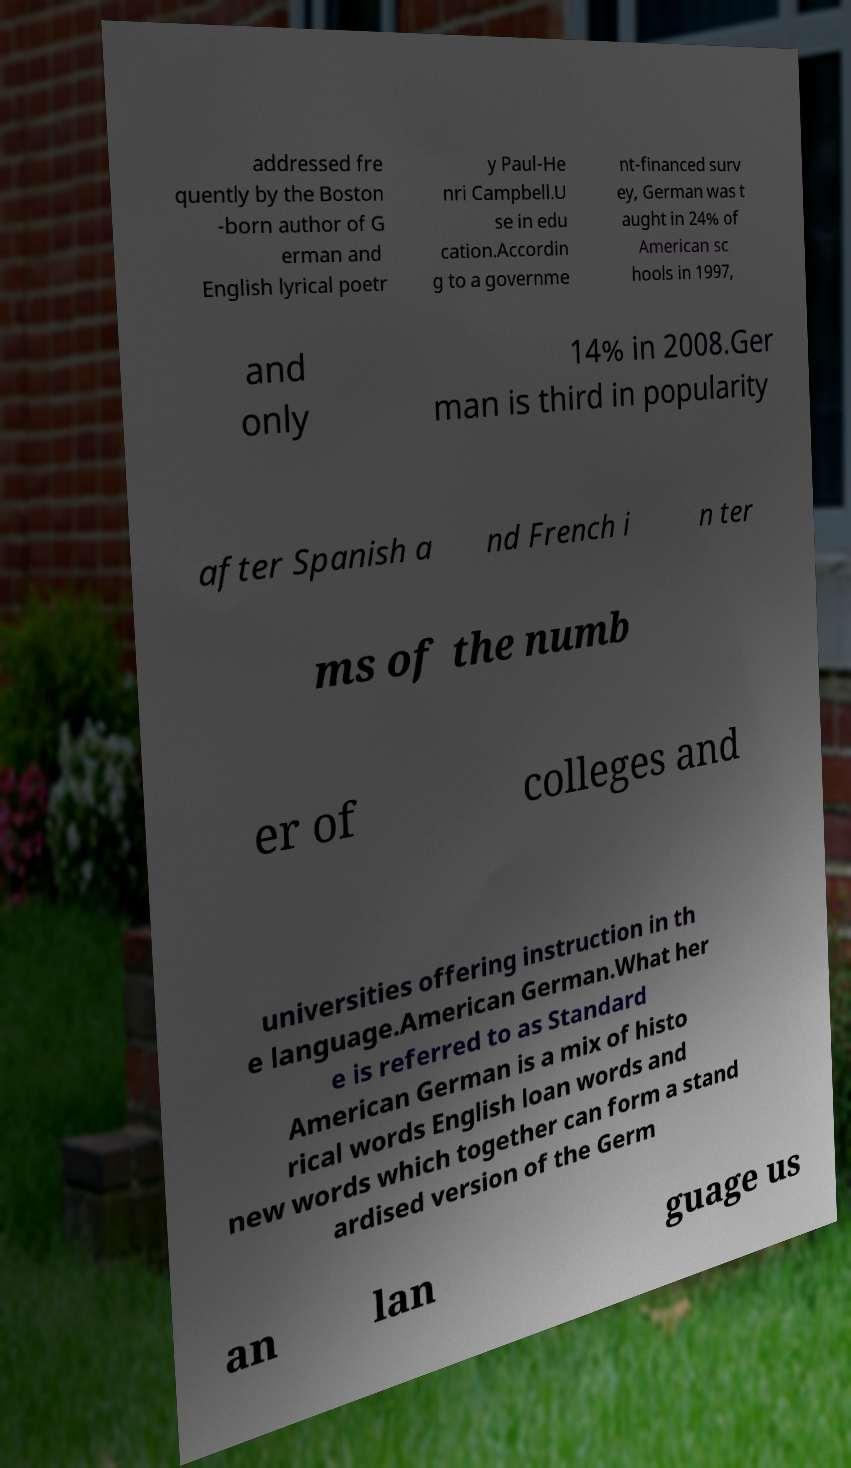For documentation purposes, I need the text within this image transcribed. Could you provide that? addressed fre quently by the Boston -born author of G erman and English lyrical poetr y Paul-He nri Campbell.U se in edu cation.Accordin g to a governme nt-financed surv ey, German was t aught in 24% of American sc hools in 1997, and only 14% in 2008.Ger man is third in popularity after Spanish a nd French i n ter ms of the numb er of colleges and universities offering instruction in th e language.American German.What her e is referred to as Standard American German is a mix of histo rical words English loan words and new words which together can form a stand ardised version of the Germ an lan guage us 